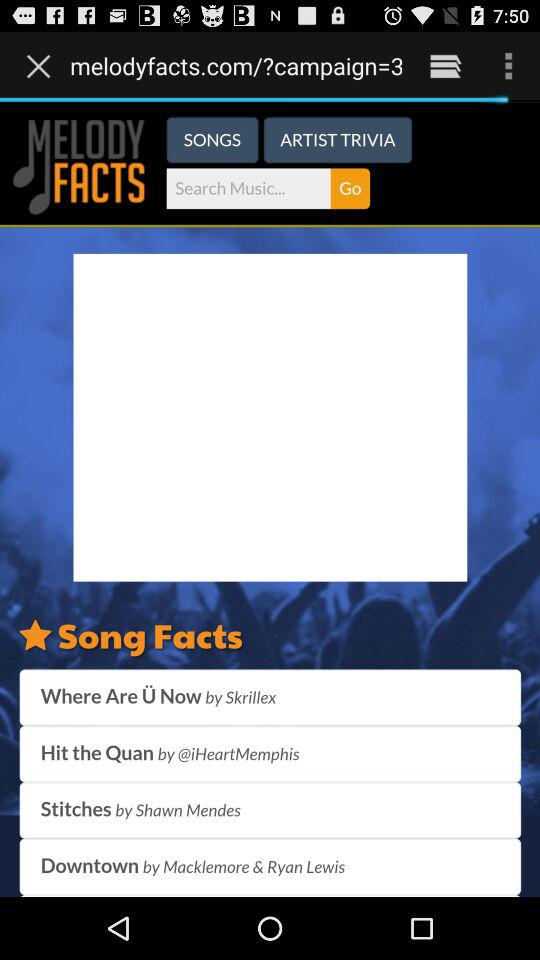Which singer sang the "Downtown" song? The song was sung by Macklemore and Ryan Lewis. 